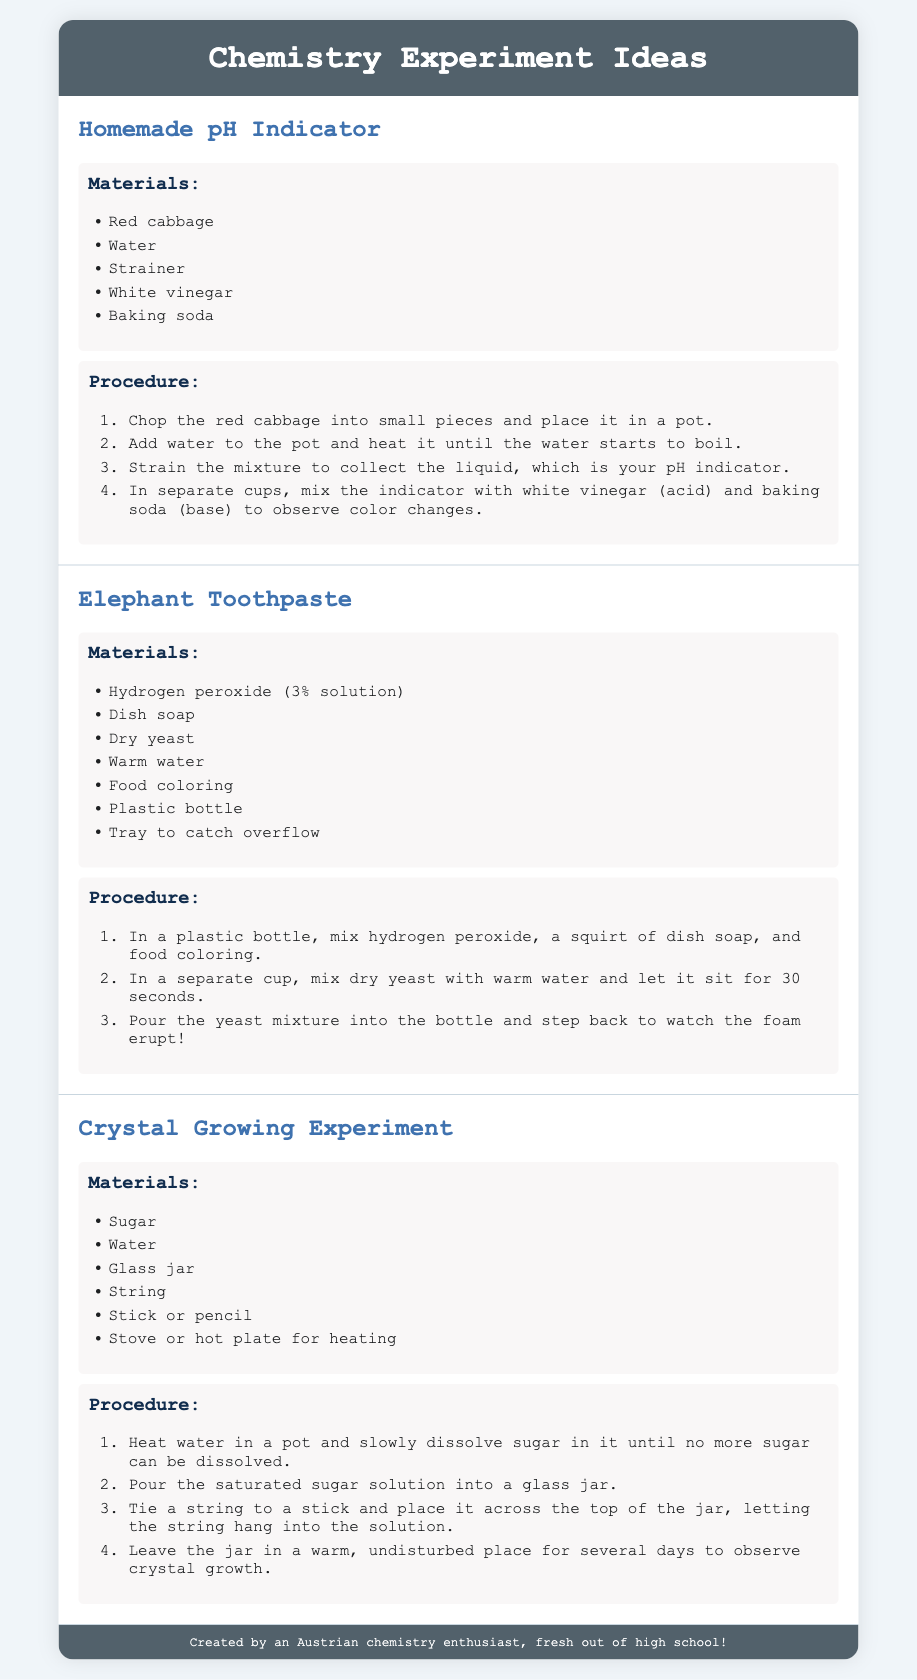What is the title of the document? The title appears at the top and introduces the content, which is a collection of chemistry experiment ideas.
Answer: Chemistry Experiment Ideas How many experiments are listed in the document? By counting the individual experiment sections, we can determine the total number of unique ideas presented.
Answer: 3 What is the first material listed in the "Homemade pH Indicator" experiment? The first material is stated in a list format under the experiment heading, providing a straightforward answer.
Answer: Red cabbage What procedure step follows mixing the indicator with white vinegar? This requires locating the procedure steps for the first experiment and identifying the sequence of actions described.
Answer: Baking soda Which experiment involves yeast as a material? The question references the specific ingredients listed for each experiment, focusing on the ones that include yeast.
Answer: Elephant Toothpaste What should you do after heating water and dissolving sugar in the "Crystal Growing Experiment"? This entails connecting the procedure action to the following step in the context of the experiment's overall goal.
Answer: Pour the saturated sugar solution into a glass jar How many types of indicators can be created using the pH indicator in the first experiment? This question requires interpreting the uses of the pH indicator as described in the procedures of the experiment.
Answer: 2 What color theme is used for the headings in the document? The color theme can be inferred from the aesthetic choices in the document's design, focusing on the color of the headings.
Answer: Blue 